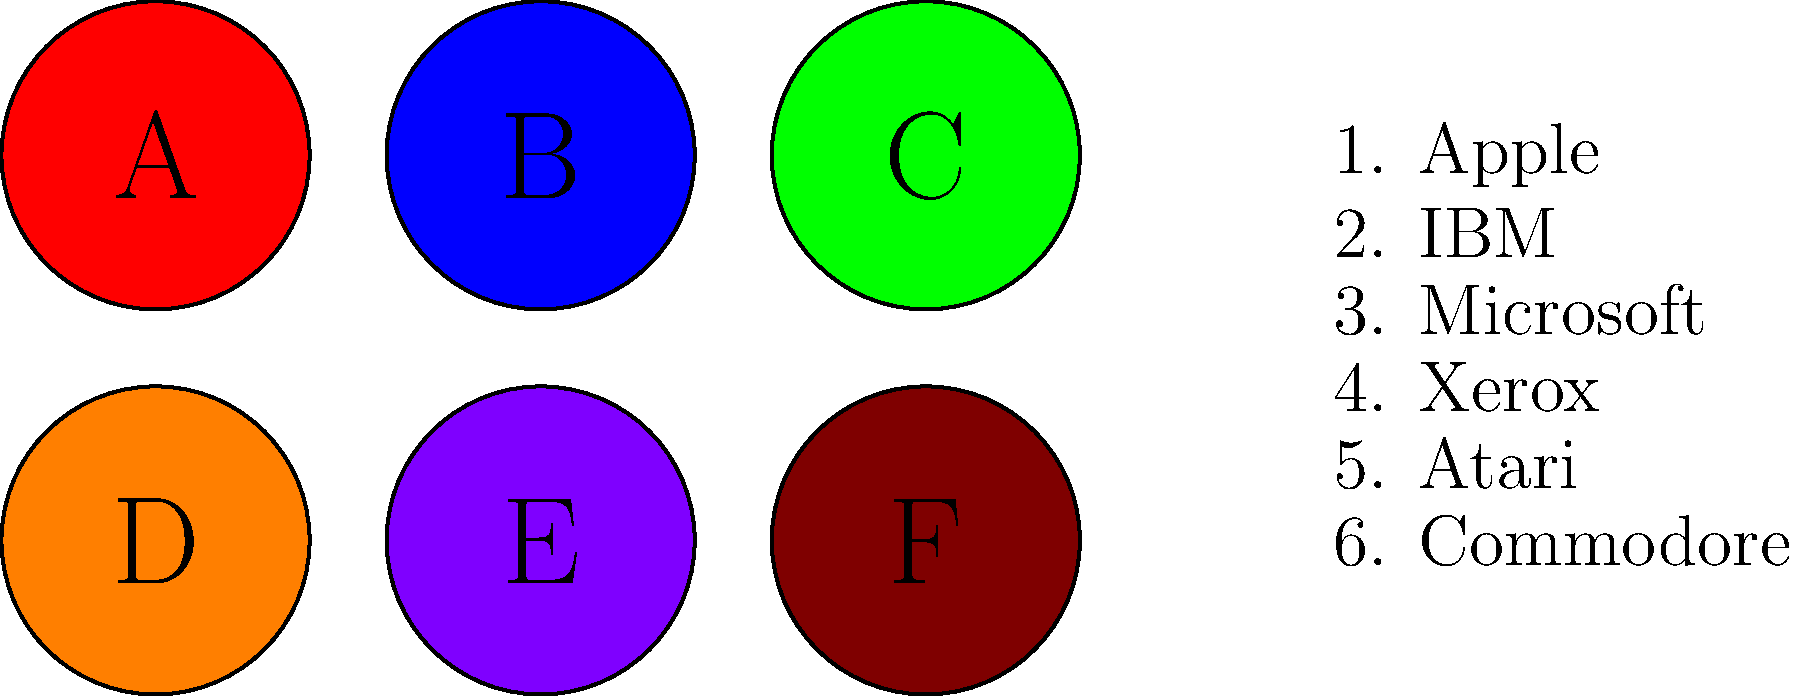Match the vintage tech logos represented by colored circles (A-F) to their corresponding company names (1-6). Which logo corresponds to IBM? To answer this question, we need to analyze the characteristics of each logo and match them to our knowledge of vintage tech company logos. Let's go through each logo:

1. Logo A (Red): This is likely the Apple logo, known for its distinctive apple shape with a bite taken out.
2. Logo B (Blue): This is most probably the IBM logo, characterized by its simple, striped letters.
3. Logo C (Green): This could represent Microsoft, which had a simple, text-based logo in its early days.
4. Logo D (Orange): This might be the Xerox logo, often represented by a bold, sans-serif font.
5. Logo E (Purple): This could be the Atari logo, known for its stylized "A" shape.
6. Logo F (Brown): This might represent Commodore, which had a simple, text-based logo in its early years.

Based on this analysis, the blue logo (B) corresponds to IBM.
Answer: B 